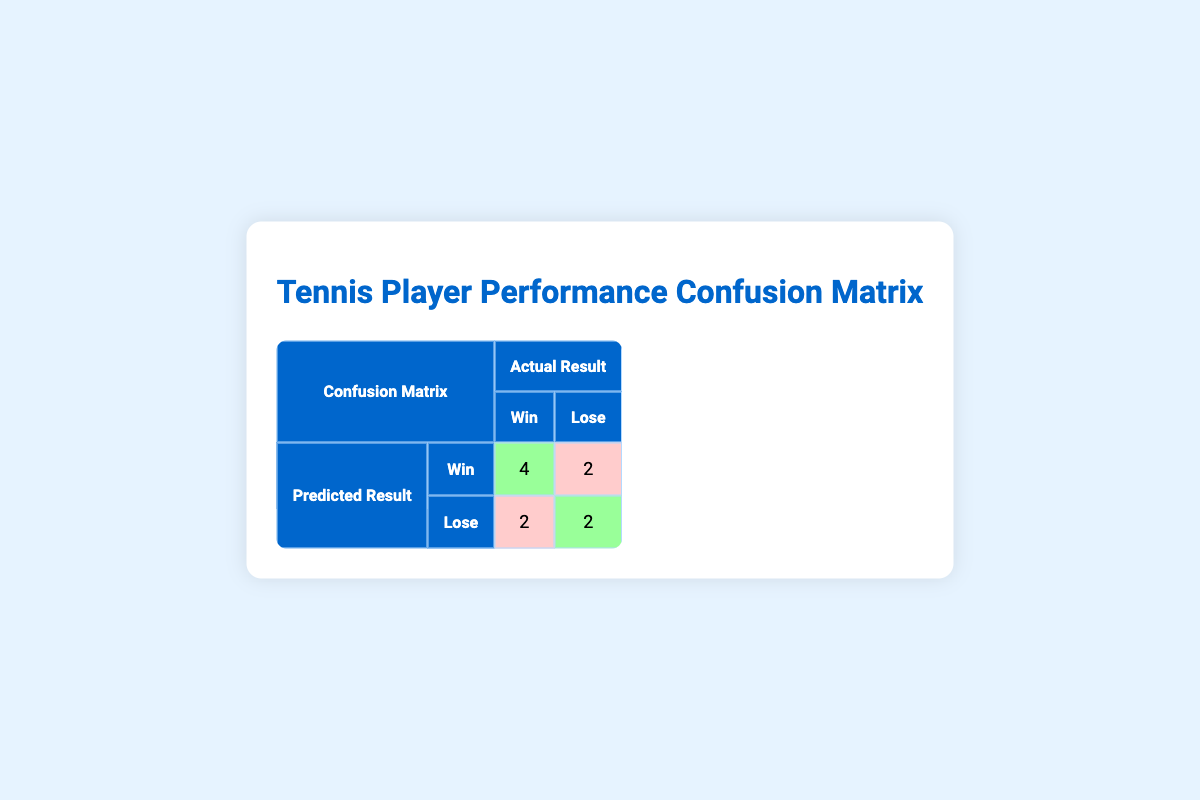What is the number of true positives in the confusion matrix? The true positives represent the number of instances where players were predicted to win and actually won. Referring to the table, the true positive count is given in the cell for predicted result "Win" and actual result "Win", which shows the value of 4.
Answer: 4 How many players were predicted to lose but actually won? This refers to the false negatives, which are counted when players were predicted to lose but still won. In the confusion matrix, this is represented in the cell for predicted result "Lose" and actual result "Win", which shows the value of 2.
Answer: 2 What is the total number of players who were predicted to win? To find this total, we need to add both true positives and false positives together. From the confusion matrix, true positives (4) and false positives (2) yield a total of 6 players predicted to win (4 + 2 = 6).
Answer: 6 Is it true that more players were predicted to lose than to win? To determine this, we compare the totals of those predicted to lose (which is 2 true negatives + 2 false negatives = 4) and those predicted to win (which is 4 true positives + 2 false positives = 6). Since 4 is less than 6, the statement is false.
Answer: No What percentage of the players predicted to lose actually lost? The percentage of players predicted to lose who actual lost is found by taking the true negatives (2) and dividing by the total predicted to lose (4) and then multiplying by 100. Thus, percentage = (2 / 4) * 100 = 50%.
Answer: 50 How many players correctly lost matches out of all predictions? This requires identifying the true negatives. According to the confusion matrix, the true negatives amount to 2. Thus, the number of players who correctly lost their matches is simply the true negative value.
Answer: 2 What is the ratio of predicted wins to actual wins? To find this ratio, we assess the predicted wins (6, which is the sum of true positives and false positives) and actual wins (6, which is the sum of true positives and false negatives). Therefore, the ratio = 6:6 simplifies to 1:1.
Answer: 1:1 What is the total number of predictions made in the confusion matrix? The total number of predictions is the sum of true positives (4), false positives (2), true negatives (2), and false negatives (2), yielding 10 total predictions (4 + 2 + 2 + 2 = 10).
Answer: 10 